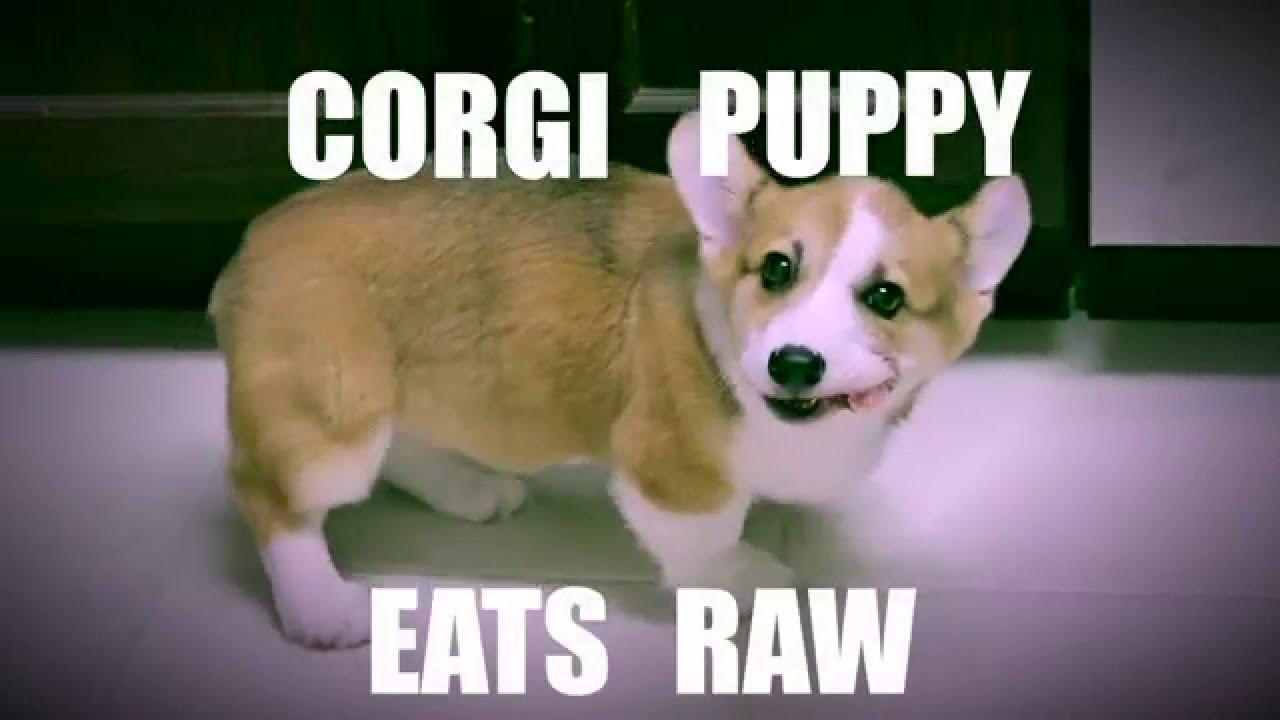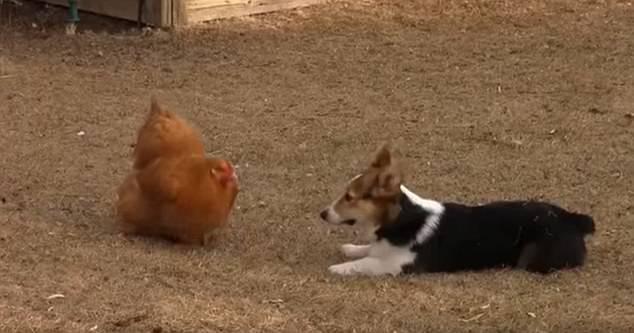The first image is the image on the left, the second image is the image on the right. Given the left and right images, does the statement "there is a dog and a chicken  in a dirt yard" hold true? Answer yes or no. Yes. The first image is the image on the left, the second image is the image on the right. Analyze the images presented: Is the assertion "In one of the images there is a dog facing a chicken." valid? Answer yes or no. Yes. 